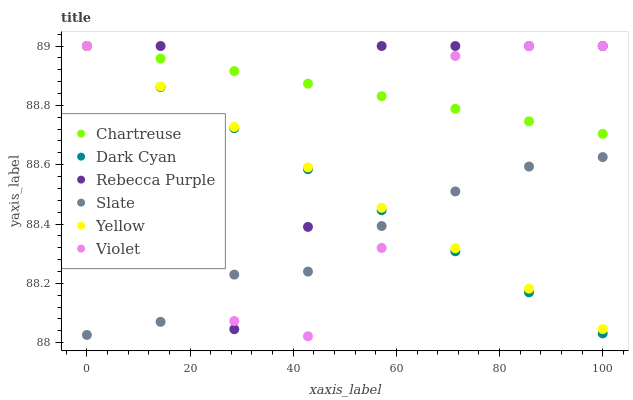Does Slate have the minimum area under the curve?
Answer yes or no. Yes. Does Chartreuse have the maximum area under the curve?
Answer yes or no. Yes. Does Yellow have the minimum area under the curve?
Answer yes or no. No. Does Yellow have the maximum area under the curve?
Answer yes or no. No. Is Chartreuse the smoothest?
Answer yes or no. Yes. Is Rebecca Purple the roughest?
Answer yes or no. Yes. Is Yellow the smoothest?
Answer yes or no. No. Is Yellow the roughest?
Answer yes or no. No. Does Violet have the lowest value?
Answer yes or no. Yes. Does Yellow have the lowest value?
Answer yes or no. No. Does Dark Cyan have the highest value?
Answer yes or no. Yes. Is Slate less than Chartreuse?
Answer yes or no. Yes. Is Chartreuse greater than Slate?
Answer yes or no. Yes. Does Dark Cyan intersect Chartreuse?
Answer yes or no. Yes. Is Dark Cyan less than Chartreuse?
Answer yes or no. No. Is Dark Cyan greater than Chartreuse?
Answer yes or no. No. Does Slate intersect Chartreuse?
Answer yes or no. No. 